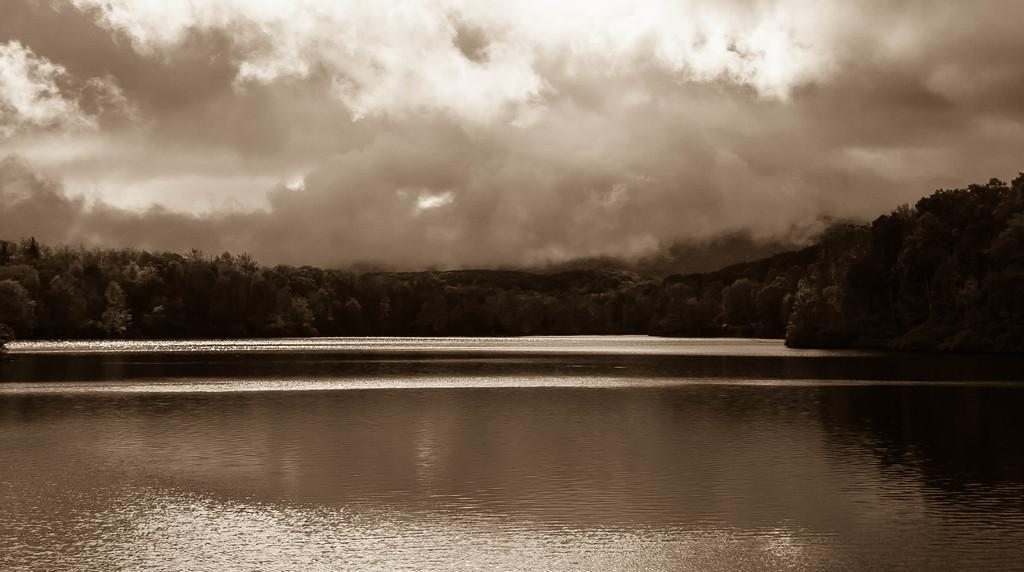What is located in the center of the image? There are trees, water, and a hill in the center of the image. What can be seen in the background of the image? The sky is visible in the background of the image, and clouds are present. How many elements are present in the center of the image? There are three elements present in the center of the image: trees, water, and a hill. What type of bait is being used to catch fish in the image? There is no fishing or bait present in the image; it features trees, water, and a hill in the center, with a sky and clouds in the background. What is the crack in the image? There is no crack present in the image. 